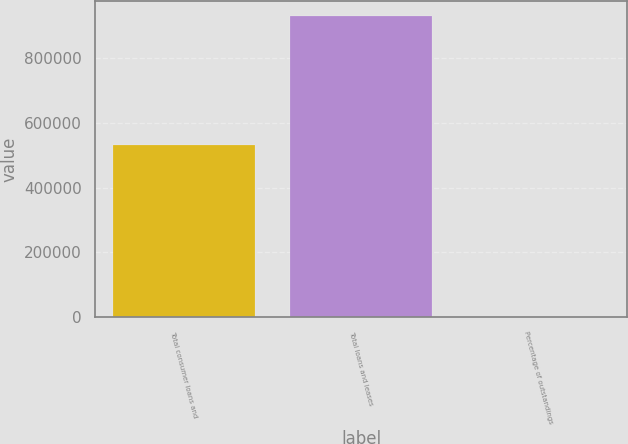Convert chart. <chart><loc_0><loc_0><loc_500><loc_500><bar_chart><fcel>Total consumer loans and<fcel>Total loans and leases<fcel>Percentage of outstandings<nl><fcel>531950<fcel>928233<fcel>100<nl></chart> 